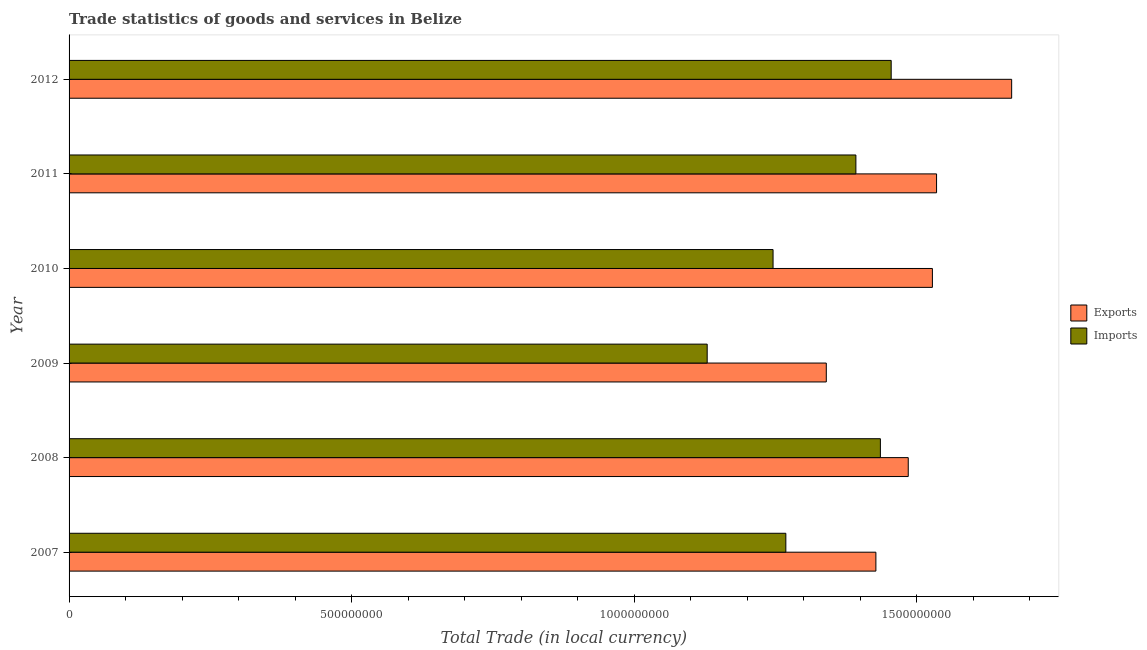How many groups of bars are there?
Give a very brief answer. 6. Are the number of bars per tick equal to the number of legend labels?
Provide a succinct answer. Yes. Are the number of bars on each tick of the Y-axis equal?
Provide a succinct answer. Yes. How many bars are there on the 2nd tick from the bottom?
Offer a terse response. 2. What is the label of the 1st group of bars from the top?
Offer a terse response. 2012. In how many cases, is the number of bars for a given year not equal to the number of legend labels?
Make the answer very short. 0. What is the imports of goods and services in 2012?
Give a very brief answer. 1.45e+09. Across all years, what is the maximum imports of goods and services?
Offer a very short reply. 1.45e+09. Across all years, what is the minimum export of goods and services?
Offer a terse response. 1.34e+09. In which year was the imports of goods and services maximum?
Your answer should be very brief. 2012. What is the total imports of goods and services in the graph?
Ensure brevity in your answer.  7.93e+09. What is the difference between the imports of goods and services in 2010 and that in 2011?
Your response must be concise. -1.47e+08. What is the difference between the imports of goods and services in 2008 and the export of goods and services in 2012?
Ensure brevity in your answer.  -2.32e+08. What is the average export of goods and services per year?
Make the answer very short. 1.50e+09. In the year 2007, what is the difference between the export of goods and services and imports of goods and services?
Offer a very short reply. 1.59e+08. In how many years, is the imports of goods and services greater than 1400000000 LCU?
Make the answer very short. 2. What is the ratio of the imports of goods and services in 2010 to that in 2011?
Give a very brief answer. 0.9. What is the difference between the highest and the second highest export of goods and services?
Your response must be concise. 1.33e+08. What is the difference between the highest and the lowest export of goods and services?
Make the answer very short. 3.28e+08. In how many years, is the export of goods and services greater than the average export of goods and services taken over all years?
Give a very brief answer. 3. What does the 1st bar from the top in 2007 represents?
Your response must be concise. Imports. What does the 2nd bar from the bottom in 2010 represents?
Ensure brevity in your answer.  Imports. Are all the bars in the graph horizontal?
Your response must be concise. Yes. How many years are there in the graph?
Your answer should be compact. 6. What is the difference between two consecutive major ticks on the X-axis?
Your response must be concise. 5.00e+08. Does the graph contain any zero values?
Your answer should be very brief. No. Where does the legend appear in the graph?
Offer a terse response. Center right. How many legend labels are there?
Offer a terse response. 2. What is the title of the graph?
Your response must be concise. Trade statistics of goods and services in Belize. What is the label or title of the X-axis?
Provide a succinct answer. Total Trade (in local currency). What is the label or title of the Y-axis?
Your answer should be compact. Year. What is the Total Trade (in local currency) of Exports in 2007?
Give a very brief answer. 1.43e+09. What is the Total Trade (in local currency) in Imports in 2007?
Provide a succinct answer. 1.27e+09. What is the Total Trade (in local currency) of Exports in 2008?
Provide a short and direct response. 1.48e+09. What is the Total Trade (in local currency) in Imports in 2008?
Make the answer very short. 1.44e+09. What is the Total Trade (in local currency) of Exports in 2009?
Keep it short and to the point. 1.34e+09. What is the Total Trade (in local currency) of Imports in 2009?
Your answer should be compact. 1.13e+09. What is the Total Trade (in local currency) in Exports in 2010?
Provide a succinct answer. 1.53e+09. What is the Total Trade (in local currency) in Imports in 2010?
Make the answer very short. 1.25e+09. What is the Total Trade (in local currency) of Exports in 2011?
Your response must be concise. 1.53e+09. What is the Total Trade (in local currency) of Imports in 2011?
Ensure brevity in your answer.  1.39e+09. What is the Total Trade (in local currency) in Exports in 2012?
Offer a terse response. 1.67e+09. What is the Total Trade (in local currency) of Imports in 2012?
Offer a terse response. 1.45e+09. Across all years, what is the maximum Total Trade (in local currency) in Exports?
Your response must be concise. 1.67e+09. Across all years, what is the maximum Total Trade (in local currency) in Imports?
Provide a succinct answer. 1.45e+09. Across all years, what is the minimum Total Trade (in local currency) in Exports?
Give a very brief answer. 1.34e+09. Across all years, what is the minimum Total Trade (in local currency) of Imports?
Provide a short and direct response. 1.13e+09. What is the total Total Trade (in local currency) in Exports in the graph?
Give a very brief answer. 8.98e+09. What is the total Total Trade (in local currency) in Imports in the graph?
Make the answer very short. 7.93e+09. What is the difference between the Total Trade (in local currency) in Exports in 2007 and that in 2008?
Your answer should be very brief. -5.73e+07. What is the difference between the Total Trade (in local currency) of Imports in 2007 and that in 2008?
Provide a succinct answer. -1.67e+08. What is the difference between the Total Trade (in local currency) of Exports in 2007 and that in 2009?
Your response must be concise. 8.78e+07. What is the difference between the Total Trade (in local currency) in Imports in 2007 and that in 2009?
Give a very brief answer. 1.39e+08. What is the difference between the Total Trade (in local currency) in Exports in 2007 and that in 2010?
Your answer should be very brief. -1.00e+08. What is the difference between the Total Trade (in local currency) in Imports in 2007 and that in 2010?
Provide a short and direct response. 2.26e+07. What is the difference between the Total Trade (in local currency) of Exports in 2007 and that in 2011?
Make the answer very short. -1.07e+08. What is the difference between the Total Trade (in local currency) of Imports in 2007 and that in 2011?
Make the answer very short. -1.24e+08. What is the difference between the Total Trade (in local currency) of Exports in 2007 and that in 2012?
Your answer should be compact. -2.40e+08. What is the difference between the Total Trade (in local currency) in Imports in 2007 and that in 2012?
Keep it short and to the point. -1.86e+08. What is the difference between the Total Trade (in local currency) in Exports in 2008 and that in 2009?
Your answer should be compact. 1.45e+08. What is the difference between the Total Trade (in local currency) of Imports in 2008 and that in 2009?
Make the answer very short. 3.06e+08. What is the difference between the Total Trade (in local currency) of Exports in 2008 and that in 2010?
Give a very brief answer. -4.27e+07. What is the difference between the Total Trade (in local currency) in Imports in 2008 and that in 2010?
Give a very brief answer. 1.90e+08. What is the difference between the Total Trade (in local currency) in Exports in 2008 and that in 2011?
Offer a very short reply. -5.01e+07. What is the difference between the Total Trade (in local currency) of Imports in 2008 and that in 2011?
Offer a terse response. 4.33e+07. What is the difference between the Total Trade (in local currency) in Exports in 2008 and that in 2012?
Provide a short and direct response. -1.83e+08. What is the difference between the Total Trade (in local currency) in Imports in 2008 and that in 2012?
Give a very brief answer. -1.91e+07. What is the difference between the Total Trade (in local currency) of Exports in 2009 and that in 2010?
Ensure brevity in your answer.  -1.88e+08. What is the difference between the Total Trade (in local currency) in Imports in 2009 and that in 2010?
Provide a succinct answer. -1.17e+08. What is the difference between the Total Trade (in local currency) in Exports in 2009 and that in 2011?
Your response must be concise. -1.95e+08. What is the difference between the Total Trade (in local currency) in Imports in 2009 and that in 2011?
Your response must be concise. -2.63e+08. What is the difference between the Total Trade (in local currency) in Exports in 2009 and that in 2012?
Your response must be concise. -3.28e+08. What is the difference between the Total Trade (in local currency) of Imports in 2009 and that in 2012?
Your answer should be compact. -3.26e+08. What is the difference between the Total Trade (in local currency) in Exports in 2010 and that in 2011?
Keep it short and to the point. -7.37e+06. What is the difference between the Total Trade (in local currency) in Imports in 2010 and that in 2011?
Offer a terse response. -1.47e+08. What is the difference between the Total Trade (in local currency) in Exports in 2010 and that in 2012?
Provide a succinct answer. -1.40e+08. What is the difference between the Total Trade (in local currency) of Imports in 2010 and that in 2012?
Keep it short and to the point. -2.09e+08. What is the difference between the Total Trade (in local currency) of Exports in 2011 and that in 2012?
Your answer should be compact. -1.33e+08. What is the difference between the Total Trade (in local currency) in Imports in 2011 and that in 2012?
Provide a short and direct response. -6.25e+07. What is the difference between the Total Trade (in local currency) of Exports in 2007 and the Total Trade (in local currency) of Imports in 2008?
Ensure brevity in your answer.  -7.97e+06. What is the difference between the Total Trade (in local currency) in Exports in 2007 and the Total Trade (in local currency) in Imports in 2009?
Your answer should be compact. 2.98e+08. What is the difference between the Total Trade (in local currency) of Exports in 2007 and the Total Trade (in local currency) of Imports in 2010?
Your answer should be compact. 1.82e+08. What is the difference between the Total Trade (in local currency) of Exports in 2007 and the Total Trade (in local currency) of Imports in 2011?
Offer a terse response. 3.54e+07. What is the difference between the Total Trade (in local currency) in Exports in 2007 and the Total Trade (in local currency) in Imports in 2012?
Provide a succinct answer. -2.71e+07. What is the difference between the Total Trade (in local currency) in Exports in 2008 and the Total Trade (in local currency) in Imports in 2009?
Provide a short and direct response. 3.56e+08. What is the difference between the Total Trade (in local currency) of Exports in 2008 and the Total Trade (in local currency) of Imports in 2010?
Ensure brevity in your answer.  2.39e+08. What is the difference between the Total Trade (in local currency) in Exports in 2008 and the Total Trade (in local currency) in Imports in 2011?
Provide a short and direct response. 9.26e+07. What is the difference between the Total Trade (in local currency) in Exports in 2008 and the Total Trade (in local currency) in Imports in 2012?
Offer a very short reply. 3.02e+07. What is the difference between the Total Trade (in local currency) of Exports in 2009 and the Total Trade (in local currency) of Imports in 2010?
Offer a very short reply. 9.42e+07. What is the difference between the Total Trade (in local currency) of Exports in 2009 and the Total Trade (in local currency) of Imports in 2011?
Your answer should be very brief. -5.24e+07. What is the difference between the Total Trade (in local currency) in Exports in 2009 and the Total Trade (in local currency) in Imports in 2012?
Your answer should be compact. -1.15e+08. What is the difference between the Total Trade (in local currency) in Exports in 2010 and the Total Trade (in local currency) in Imports in 2011?
Your answer should be very brief. 1.35e+08. What is the difference between the Total Trade (in local currency) of Exports in 2010 and the Total Trade (in local currency) of Imports in 2012?
Offer a very short reply. 7.29e+07. What is the difference between the Total Trade (in local currency) in Exports in 2011 and the Total Trade (in local currency) in Imports in 2012?
Provide a short and direct response. 8.03e+07. What is the average Total Trade (in local currency) of Exports per year?
Offer a terse response. 1.50e+09. What is the average Total Trade (in local currency) in Imports per year?
Make the answer very short. 1.32e+09. In the year 2007, what is the difference between the Total Trade (in local currency) of Exports and Total Trade (in local currency) of Imports?
Offer a terse response. 1.59e+08. In the year 2008, what is the difference between the Total Trade (in local currency) in Exports and Total Trade (in local currency) in Imports?
Provide a succinct answer. 4.93e+07. In the year 2009, what is the difference between the Total Trade (in local currency) in Exports and Total Trade (in local currency) in Imports?
Make the answer very short. 2.11e+08. In the year 2010, what is the difference between the Total Trade (in local currency) in Exports and Total Trade (in local currency) in Imports?
Give a very brief answer. 2.82e+08. In the year 2011, what is the difference between the Total Trade (in local currency) in Exports and Total Trade (in local currency) in Imports?
Provide a short and direct response. 1.43e+08. In the year 2012, what is the difference between the Total Trade (in local currency) in Exports and Total Trade (in local currency) in Imports?
Provide a short and direct response. 2.13e+08. What is the ratio of the Total Trade (in local currency) in Exports in 2007 to that in 2008?
Provide a short and direct response. 0.96. What is the ratio of the Total Trade (in local currency) in Imports in 2007 to that in 2008?
Offer a terse response. 0.88. What is the ratio of the Total Trade (in local currency) in Exports in 2007 to that in 2009?
Provide a succinct answer. 1.07. What is the ratio of the Total Trade (in local currency) in Imports in 2007 to that in 2009?
Provide a succinct answer. 1.12. What is the ratio of the Total Trade (in local currency) of Exports in 2007 to that in 2010?
Give a very brief answer. 0.93. What is the ratio of the Total Trade (in local currency) of Imports in 2007 to that in 2010?
Offer a very short reply. 1.02. What is the ratio of the Total Trade (in local currency) of Exports in 2007 to that in 2011?
Provide a short and direct response. 0.93. What is the ratio of the Total Trade (in local currency) of Imports in 2007 to that in 2011?
Give a very brief answer. 0.91. What is the ratio of the Total Trade (in local currency) in Exports in 2007 to that in 2012?
Keep it short and to the point. 0.86. What is the ratio of the Total Trade (in local currency) of Imports in 2007 to that in 2012?
Your answer should be very brief. 0.87. What is the ratio of the Total Trade (in local currency) of Exports in 2008 to that in 2009?
Provide a short and direct response. 1.11. What is the ratio of the Total Trade (in local currency) in Imports in 2008 to that in 2009?
Your answer should be very brief. 1.27. What is the ratio of the Total Trade (in local currency) of Exports in 2008 to that in 2010?
Provide a short and direct response. 0.97. What is the ratio of the Total Trade (in local currency) of Imports in 2008 to that in 2010?
Make the answer very short. 1.15. What is the ratio of the Total Trade (in local currency) of Exports in 2008 to that in 2011?
Offer a very short reply. 0.97. What is the ratio of the Total Trade (in local currency) of Imports in 2008 to that in 2011?
Offer a very short reply. 1.03. What is the ratio of the Total Trade (in local currency) of Exports in 2008 to that in 2012?
Ensure brevity in your answer.  0.89. What is the ratio of the Total Trade (in local currency) in Imports in 2008 to that in 2012?
Your response must be concise. 0.99. What is the ratio of the Total Trade (in local currency) of Exports in 2009 to that in 2010?
Your answer should be very brief. 0.88. What is the ratio of the Total Trade (in local currency) in Imports in 2009 to that in 2010?
Your answer should be very brief. 0.91. What is the ratio of the Total Trade (in local currency) of Exports in 2009 to that in 2011?
Offer a terse response. 0.87. What is the ratio of the Total Trade (in local currency) in Imports in 2009 to that in 2011?
Your answer should be very brief. 0.81. What is the ratio of the Total Trade (in local currency) in Exports in 2009 to that in 2012?
Your answer should be compact. 0.8. What is the ratio of the Total Trade (in local currency) of Imports in 2009 to that in 2012?
Give a very brief answer. 0.78. What is the ratio of the Total Trade (in local currency) in Imports in 2010 to that in 2011?
Your answer should be compact. 0.89. What is the ratio of the Total Trade (in local currency) of Exports in 2010 to that in 2012?
Offer a very short reply. 0.92. What is the ratio of the Total Trade (in local currency) of Imports in 2010 to that in 2012?
Offer a terse response. 0.86. What is the ratio of the Total Trade (in local currency) of Exports in 2011 to that in 2012?
Give a very brief answer. 0.92. What is the ratio of the Total Trade (in local currency) in Imports in 2011 to that in 2012?
Ensure brevity in your answer.  0.96. What is the difference between the highest and the second highest Total Trade (in local currency) of Exports?
Offer a very short reply. 1.33e+08. What is the difference between the highest and the second highest Total Trade (in local currency) in Imports?
Give a very brief answer. 1.91e+07. What is the difference between the highest and the lowest Total Trade (in local currency) in Exports?
Make the answer very short. 3.28e+08. What is the difference between the highest and the lowest Total Trade (in local currency) in Imports?
Keep it short and to the point. 3.26e+08. 